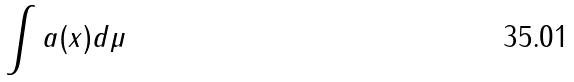Convert formula to latex. <formula><loc_0><loc_0><loc_500><loc_500>\int a ( x ) d \mu</formula> 